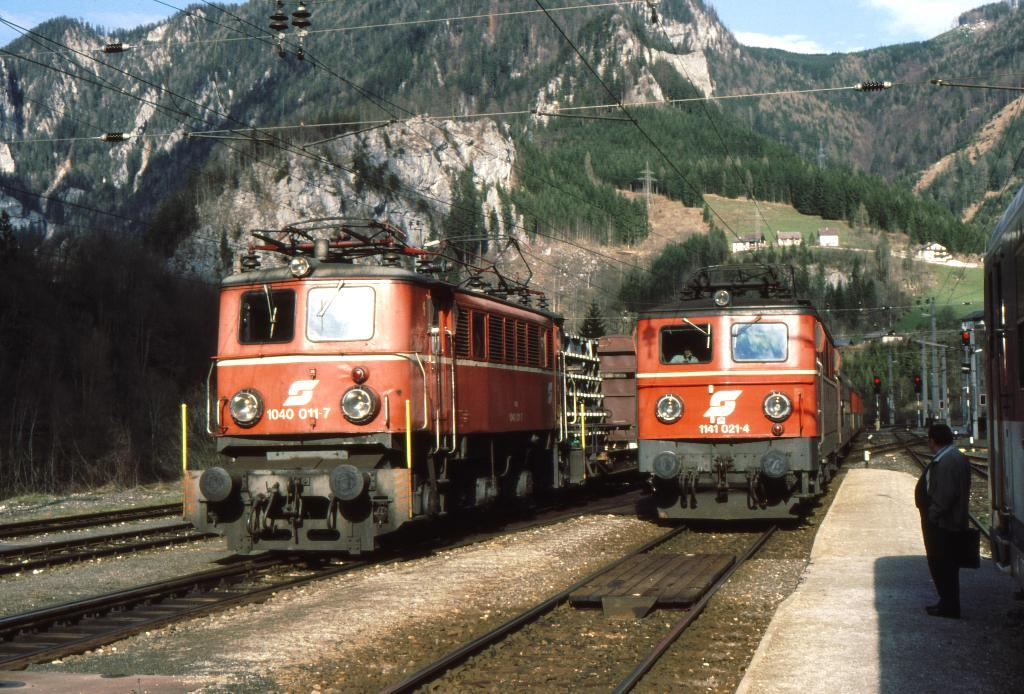Provide a one-sentence caption for the provided image. Train 1040 011-7 is parked next to another train on the track. 